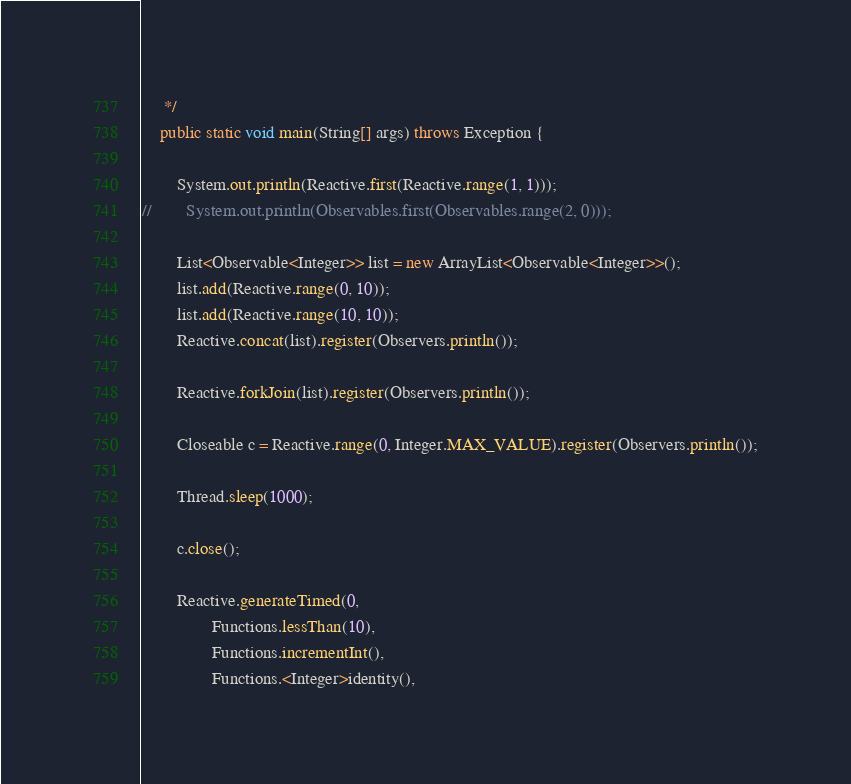<code> <loc_0><loc_0><loc_500><loc_500><_Java_>     */
    public static void main(String[] args) throws Exception {

        System.out.println(Reactive.first(Reactive.range(1, 1)));
//        System.out.println(Observables.first(Observables.range(2, 0)));
        
        List<Observable<Integer>> list = new ArrayList<Observable<Integer>>();
        list.add(Reactive.range(0, 10));
        list.add(Reactive.range(10, 10));
        Reactive.concat(list).register(Observers.println());
        
        Reactive.forkJoin(list).register(Observers.println());
        
        Closeable c = Reactive.range(0, Integer.MAX_VALUE).register(Observers.println());
        
        Thread.sleep(1000);
        
        c.close();
        
        Reactive.generateTimed(0, 
                Functions.lessThan(10), 
                Functions.incrementInt(), 
                Functions.<Integer>identity(), </code> 